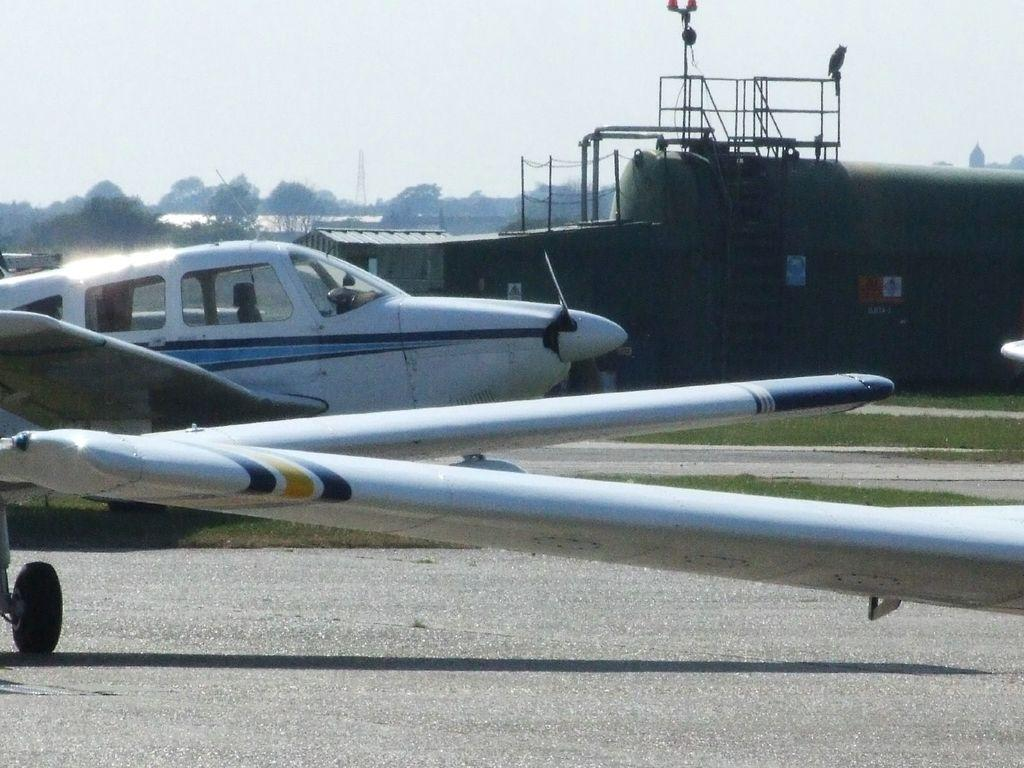What is unusual about the scene in the image? There are aircraft on the road in the image, which is not a typical place for them to be. What can be seen in the background of the image? There is a shed, many trees, a tower, and the sky visible in the background of the image. What type of jam is being served at the nation's idea in the image? There is no jam, nation, or idea present in the image; it features aircraft on the road and a background with a shed, trees, a tower, and the sky. 